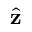<formula> <loc_0><loc_0><loc_500><loc_500>\hat { z }</formula> 